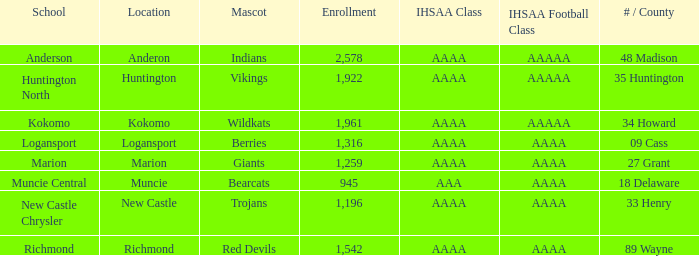What's the IHSAA class of the Red Devils? AAAA. Parse the table in full. {'header': ['School', 'Location', 'Mascot', 'Enrollment', 'IHSAA Class', 'IHSAA Football Class', '# / County'], 'rows': [['Anderson', 'Anderon', 'Indians', '2,578', 'AAAA', 'AAAAA', '48 Madison'], ['Huntington North', 'Huntington', 'Vikings', '1,922', 'AAAA', 'AAAAA', '35 Huntington'], ['Kokomo', 'Kokomo', 'Wildkats', '1,961', 'AAAA', 'AAAAA', '34 Howard'], ['Logansport', 'Logansport', 'Berries', '1,316', 'AAAA', 'AAAA', '09 Cass'], ['Marion', 'Marion', 'Giants', '1,259', 'AAAA', 'AAAA', '27 Grant'], ['Muncie Central', 'Muncie', 'Bearcats', '945', 'AAA', 'AAAA', '18 Delaware'], ['New Castle Chrysler', 'New Castle', 'Trojans', '1,196', 'AAAA', 'AAAA', '33 Henry'], ['Richmond', 'Richmond', 'Red Devils', '1,542', 'AAAA', 'AAAA', '89 Wayne']]} 